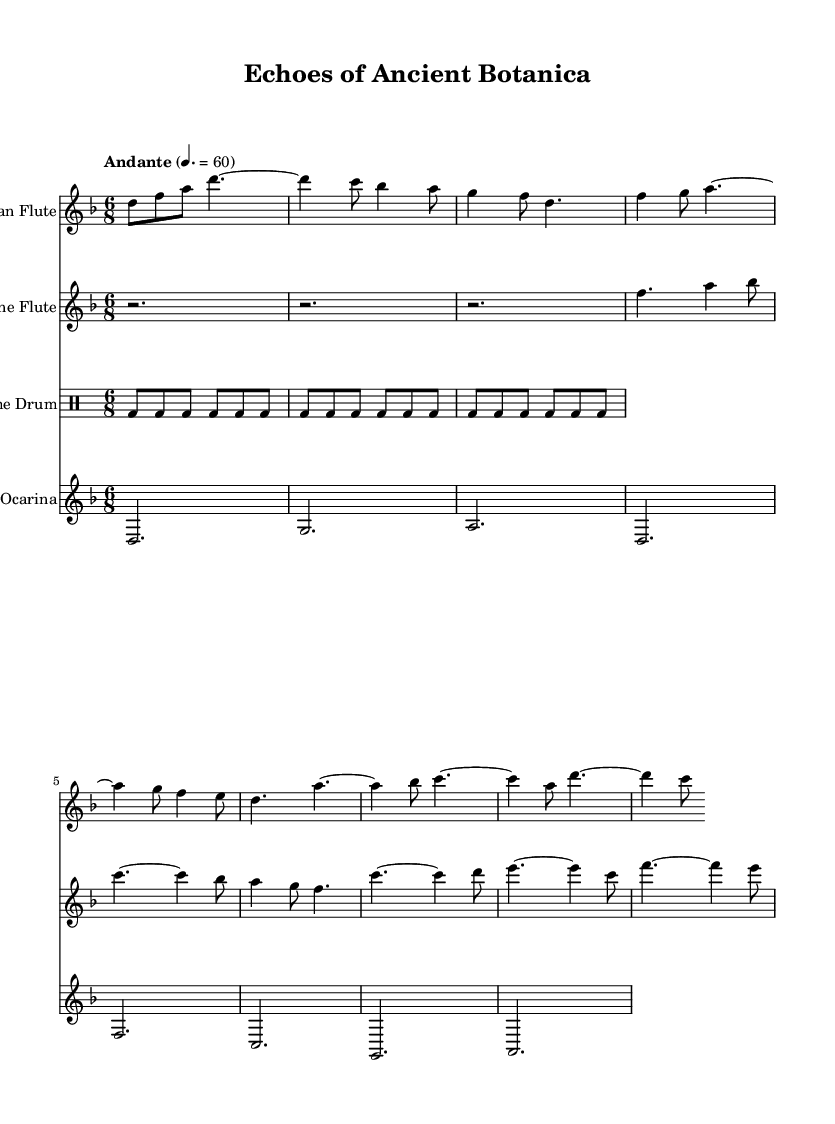What is the key signature of this music? The key signature is identified through the presence of sharps or flats at the beginning of the staff. In this case, there are no sharps or flats indicated, which suggests that the key signature is D minor, as indicated in the global section.
Answer: D minor What is the time signature of this composition? The time signature is indicated at the beginning of the staff, and it is represented as a fraction. Here, it shows 6/8, which means there are six eighth notes per measure.
Answer: 6/8 What is the tempo marking for this piece? The tempo marking is typically indicated at the beginning of the composition, where it specifies the speed at which the music should be played. The marking here is "Andante," with a metronome marking of 60 beats per minute, suggesting a moderate pace.
Answer: Andante Which instruments are featured in this sheet music? The instruments are specified at the beginning of each staff within the score. Upon review of the score, the instruments listed include Pan Flute, Bone Flute, Frame Drum, and Clay Ocarina.
Answer: Pan Flute, Bone Flute, Frame Drum, Clay Ocarina How many measures does the Pan Flute part contain? To find the number of measures, we count each grouping of notes and rests separated by a vertical line (bar line) on the staff for the Pan Flute part. There are eight measures in total in this section.
Answer: 8 What is the rhythmic pattern of the Frame Drum? The rhythmic pattern for the Frame Drum part consists of sixteenth note beats marked with 'bd' repeated six times per measure. This consistent rhythm contributes to the underlying beat of the composition.
Answer: Sixteenth notes What note holds the longest duration in the Clay Ocarina part? Looking through the note values in the Clay Ocarina part, we can identify that the longest note value present is the dotted half note (represented as d2.) which holds the longest duration in this section.
Answer: Dotted half note 